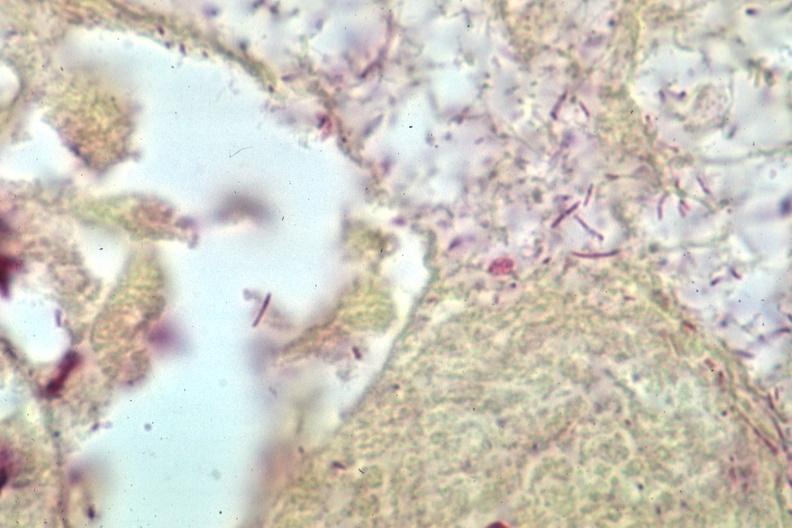does grams stain gram negative bacteria?
Answer the question using a single word or phrase. Yes 